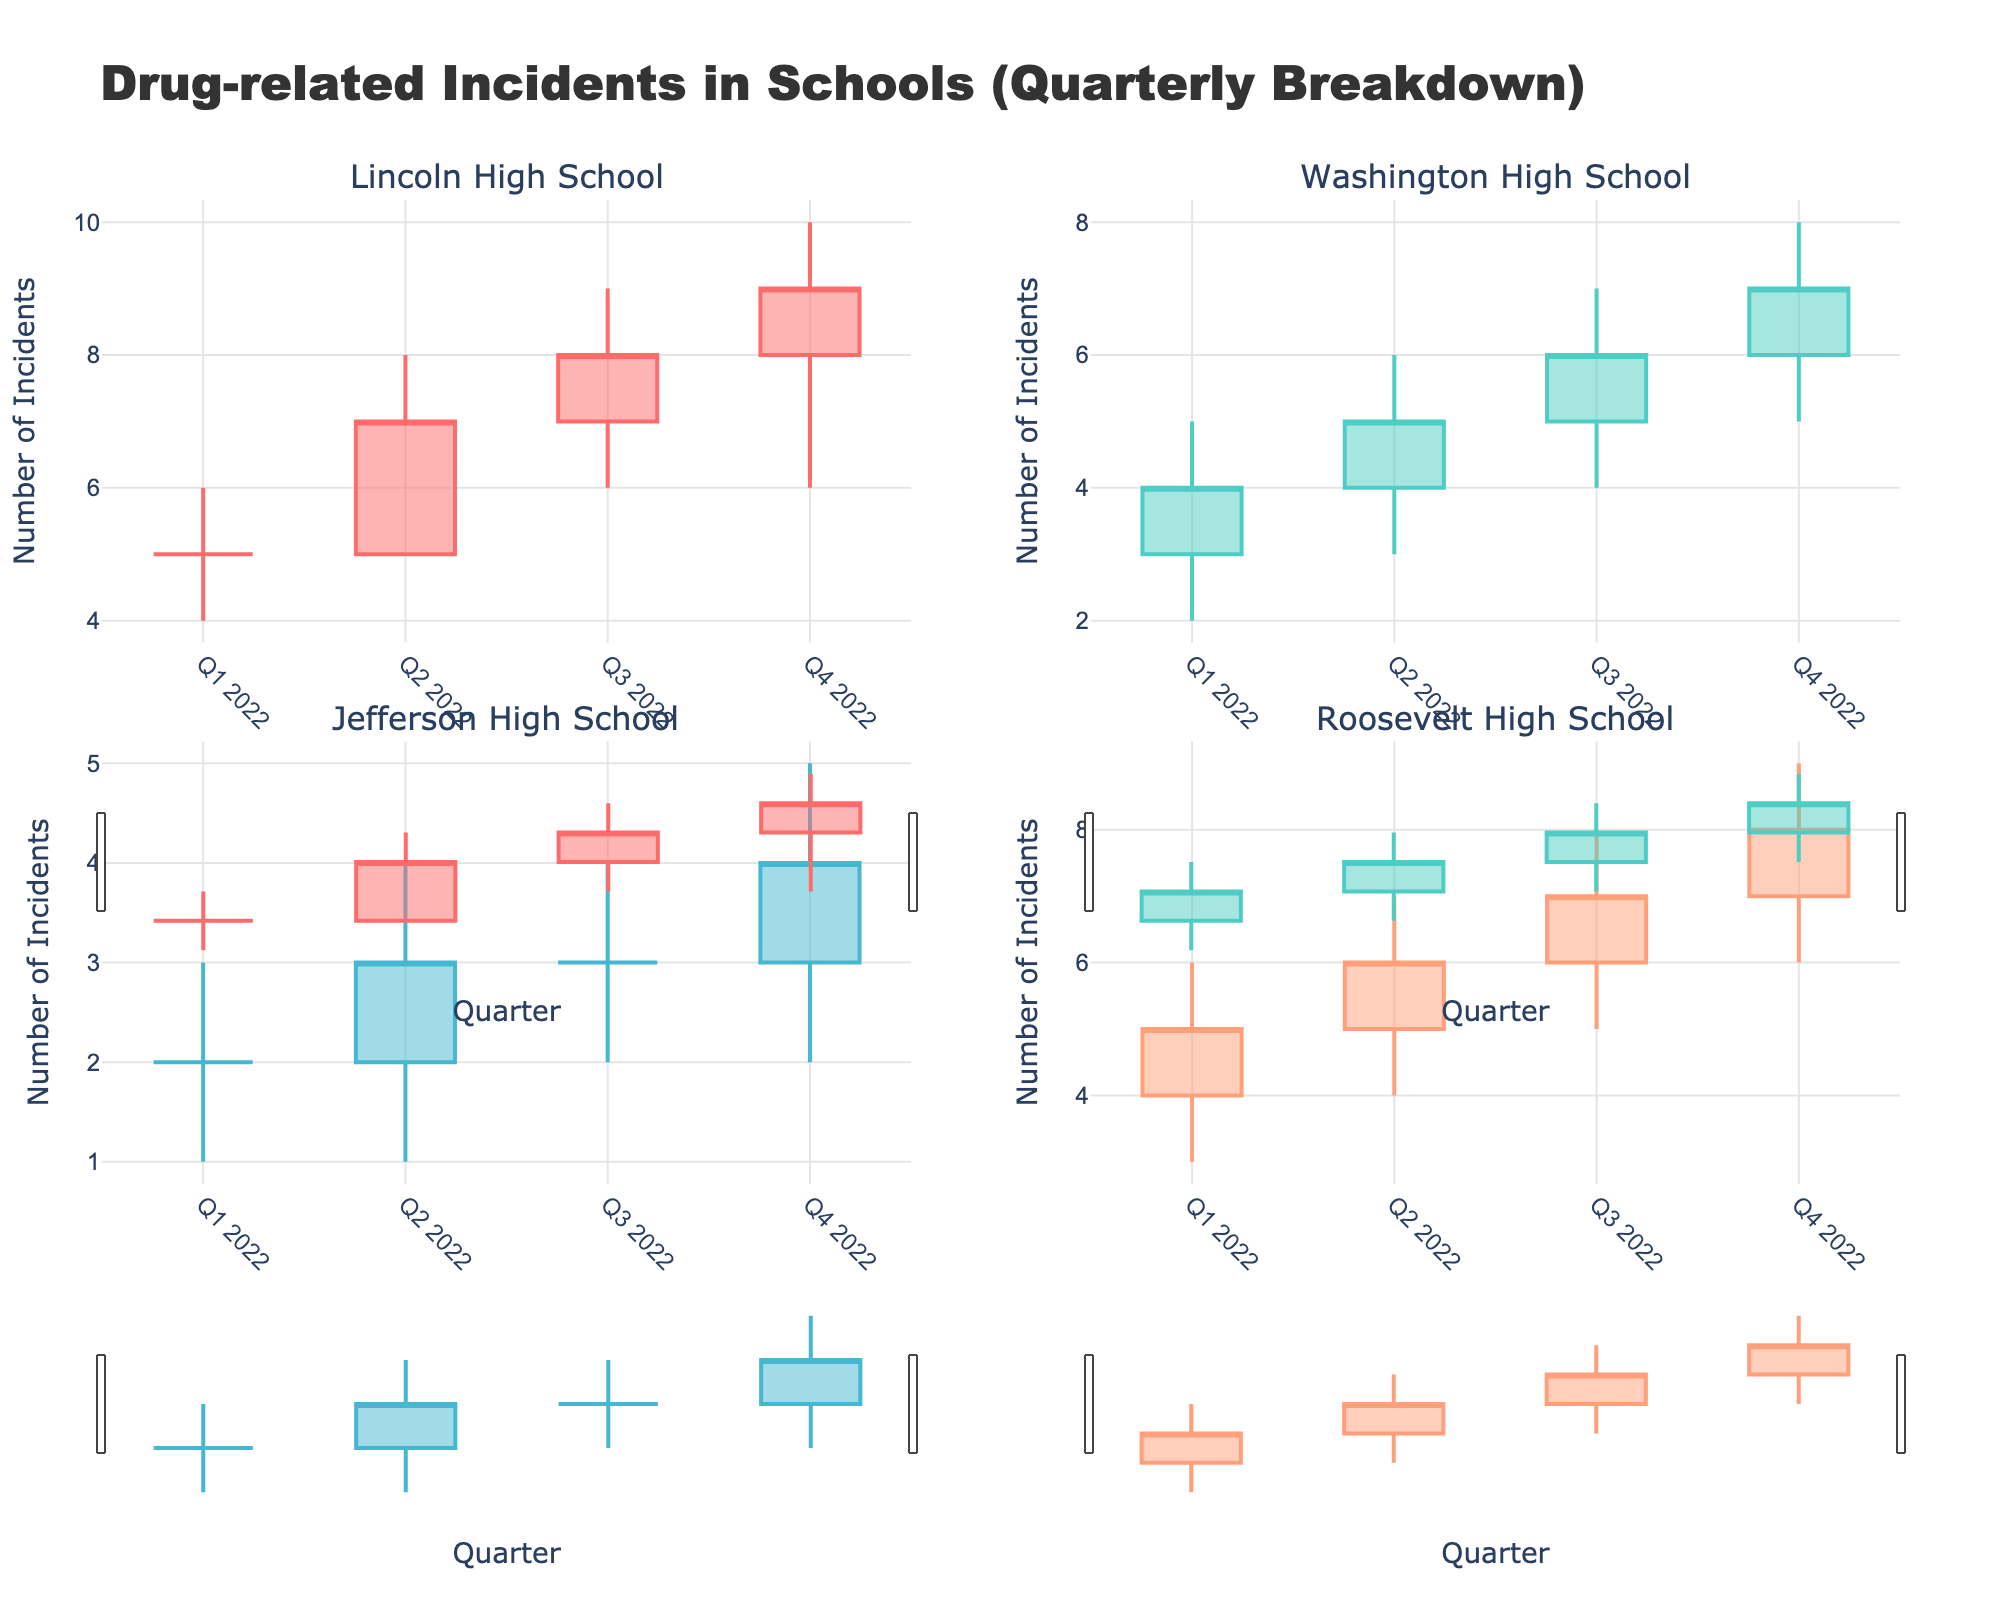What is the title of the figure? The title is usually displayed at the top of the figure. It provides a summary of what the figure is about.
Answer: Drug-related Incidents in Schools (Quarterly Breakdown) How many schools are compared in the figure? We count the number of subplot titles, each represented by a different school. Here, there are four subplots.
Answer: Four Which school experienced the highest number of incidents in any quarter, and in which quarter did this occur? Identify the highest value on the "High" axis for each subplot. Lincoln High School in Q4 2022 shows a high value of 10.
Answer: Lincoln High School, Q4 2022 What's the trend of drug-related incidents at Lincoln High School over the year? Look at the candlestick plot for Lincoln High School: starting from Q1 to Q4, both the open and close values are increasing.
Answer: Increasing Which quarter had the lowest high value for Washington High School? Find the lowest high value for the corresponding subplot. In Q1 2022, Washington High School has a high value of 5, which is the lowest.
Answer: Q1 2022 Compare the closing values of Roosevelt High School in Q1 2022 and Jefferson High School in Q1 2022. Look at the "Close" marks for Q1 2022 in both schools' subplots. Roosevelt High School closed at 5, and Jefferson High School closed at 2.
Answer: Roosevelt High School: 5, Jefferson High School: 2 What is the average closing value for Jefferson High School in the four quarters of 2022? Identify the closing values in each quarter from Q1 to Q4, summing them up and dividing by four: (2 + 3 + 3 + 4)/4 = 12/4 = 3.
Answer: 3 How did the range of incidents (difference between high and low values) in Q4 2022 compare between Lincoln High School and Roosevelt High School? Subtract the low value from the high value for both schools in Q4 2022: Lincoln High School (10-6 = 4), Roosevelt High School (9-6 = 3).
Answer: Lincoln: 4, Roosevelt: 3 Is there a quarter where Jefferson High School had more incidents close than open? Compare the close and open values for each quarter in Jefferson High School's subplot. Q2 2022 and Q4 2022 have close values greater than open values.
Answer: Q2 2022, Q4 2022 